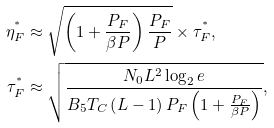Convert formula to latex. <formula><loc_0><loc_0><loc_500><loc_500>\eta _ { F } ^ { ^ { * } } & \approx \sqrt { \left ( 1 + \frac { P _ { F } } { \beta P } \right ) \frac { P _ { F } } { P } } \times \tau _ { F } ^ { ^ { * } } , \\ \tau _ { F } ^ { ^ { * } } & \approx \sqrt { \frac { N _ { 0 } L ^ { 2 } \log _ { 2 } e } { B _ { 5 } T _ { C } \left ( L - 1 \right ) P _ { F } \left ( 1 + \frac { P _ { F } } { \beta P } \right ) } } ,</formula> 